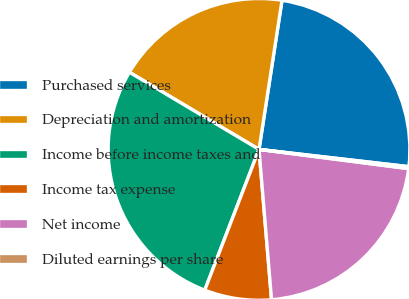<chart> <loc_0><loc_0><loc_500><loc_500><pie_chart><fcel>Purchased services<fcel>Depreciation and amortization<fcel>Income before income taxes and<fcel>Income tax expense<fcel>Net income<fcel>Diluted earnings per share<nl><fcel>24.39%<fcel>18.89%<fcel>27.69%<fcel>7.18%<fcel>21.64%<fcel>0.21%<nl></chart> 